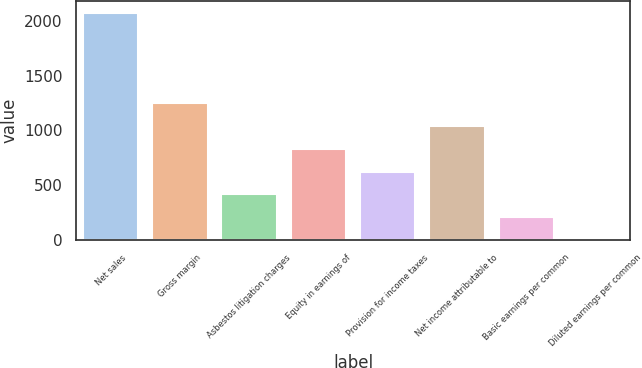Convert chart to OTSL. <chart><loc_0><loc_0><loc_500><loc_500><bar_chart><fcel>Net sales<fcel>Gross margin<fcel>Asbestos litigation charges<fcel>Equity in earnings of<fcel>Provision for income taxes<fcel>Net income attributable to<fcel>Basic earnings per common<fcel>Diluted earnings per common<nl><fcel>2075<fcel>1245.21<fcel>415.41<fcel>830.31<fcel>622.86<fcel>1037.76<fcel>207.96<fcel>0.51<nl></chart> 